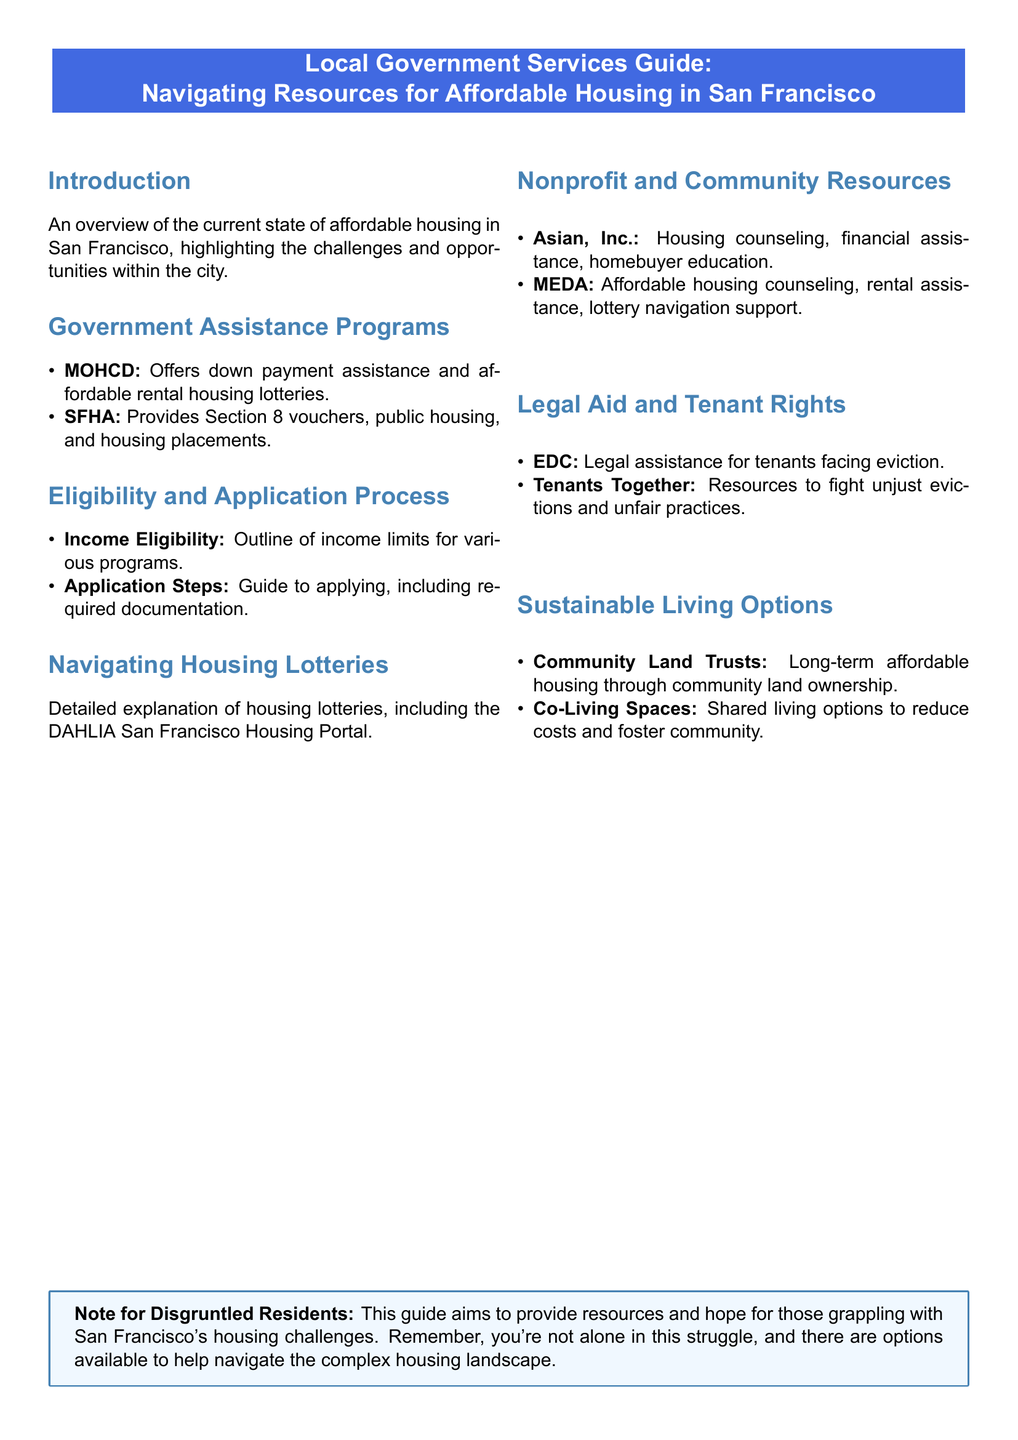What government assistance program offers down payment assistance? The document states that MOHCD offers down payment assistance.
Answer: MOHCD What does SFHA provide? SFHA provides Section 8 vouchers, public housing, and housing placements.
Answer: Section 8 vouchers What is the purpose of the DAHLIA San Francisco Housing Portal? DAHLIA San Francisco Housing Portal is used for housing lotteries.
Answer: Housing lotteries Which organization offers housing counseling? The document mentions Asian, Inc. for housing counseling.
Answer: Asian, Inc What legal aid is available for tenants facing eviction? EDC provides legal assistance for tenants facing eviction.
Answer: EDC What is one option for sustainable living mentioned in the document? The document lists Community Land Trusts as a sustainable living option.
Answer: Community Land Trusts What type of assistance does MEDA provide? MEDA offers affordable housing counseling and rental assistance.
Answer: Affordable housing counseling What should disgruntled residents remember according to the note? The note emphasizes that residents are not alone in their struggle.
Answer: Not alone What kind of shared living option is mentioned? Co-Living Spaces are mentioned as shared living options.
Answer: Co-Living Spaces 